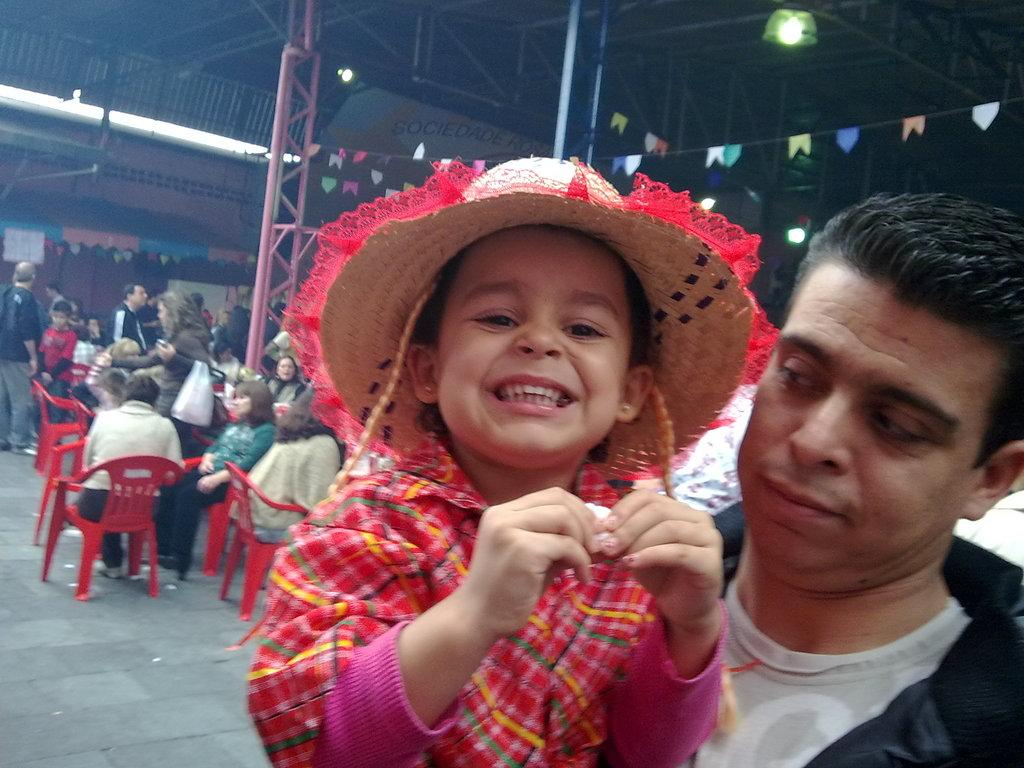What is the primary action being performed by the person in the image? The person in the image is carrying a child. What can be observed in the background of the image? There are many people sitting on chairs in the background of the image. What type of fuel is being used by the train in the image? There is no train present in the image, so it is not possible to determine what type of fuel might be used. 